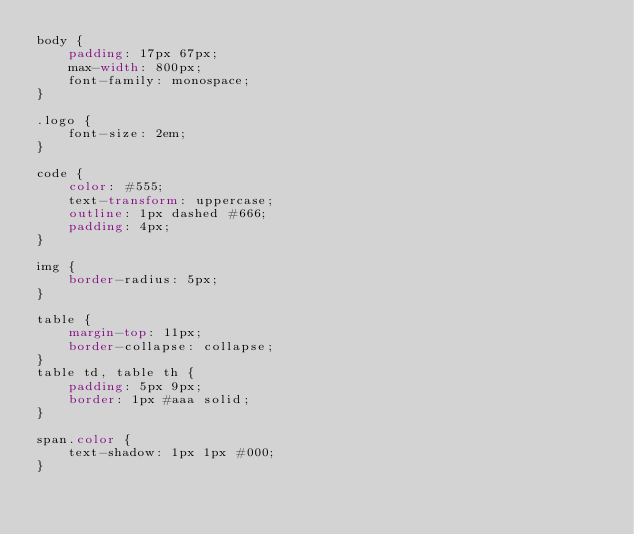<code> <loc_0><loc_0><loc_500><loc_500><_CSS_>body {
    padding: 17px 67px;
    max-width: 800px;
    font-family: monospace;
}

.logo {
    font-size: 2em;
}

code {
    color: #555;
    text-transform: uppercase;
    outline: 1px dashed #666;
    padding: 4px;
}

img {
    border-radius: 5px;
}

table {
    margin-top: 11px;
    border-collapse: collapse;
}
table td, table th {
    padding: 5px 9px;
    border: 1px #aaa solid;
}

span.color {
    text-shadow: 1px 1px #000;
}
</code> 